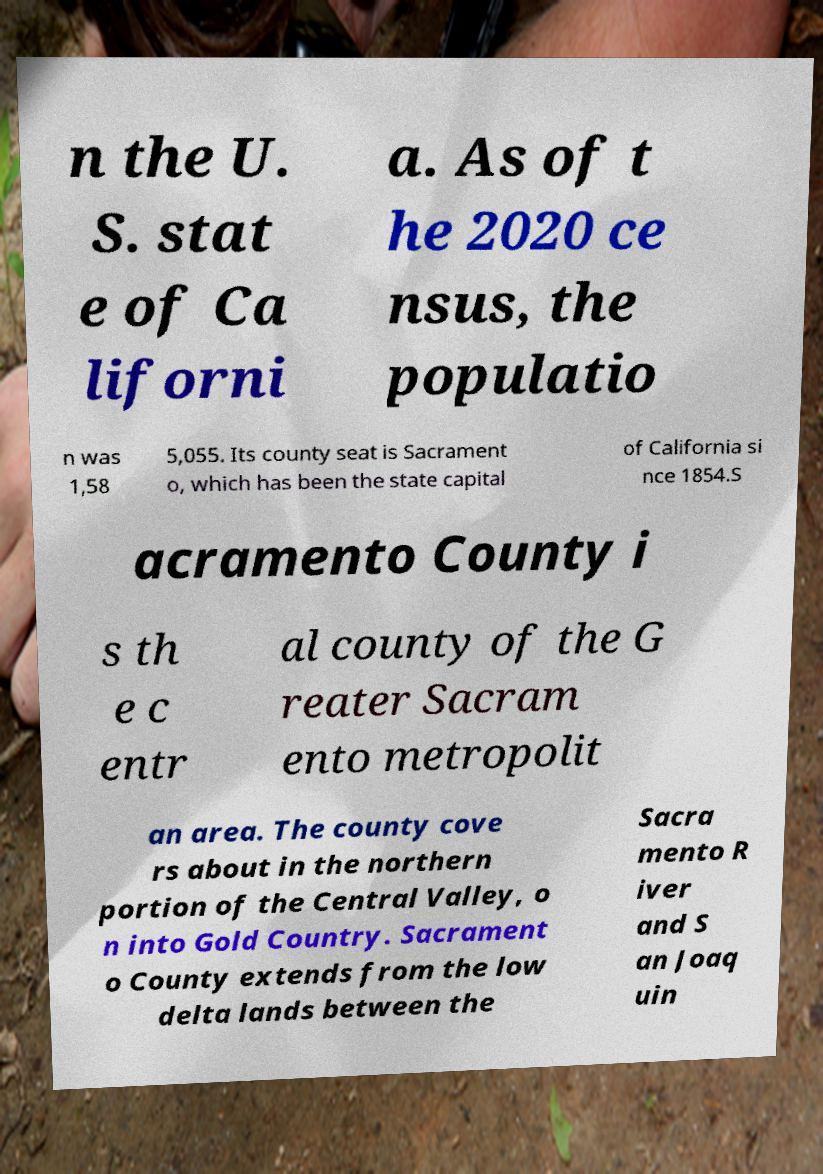What messages or text are displayed in this image? I need them in a readable, typed format. n the U. S. stat e of Ca liforni a. As of t he 2020 ce nsus, the populatio n was 1,58 5,055. Its county seat is Sacrament o, which has been the state capital of California si nce 1854.S acramento County i s th e c entr al county of the G reater Sacram ento metropolit an area. The county cove rs about in the northern portion of the Central Valley, o n into Gold Country. Sacrament o County extends from the low delta lands between the Sacra mento R iver and S an Joaq uin 